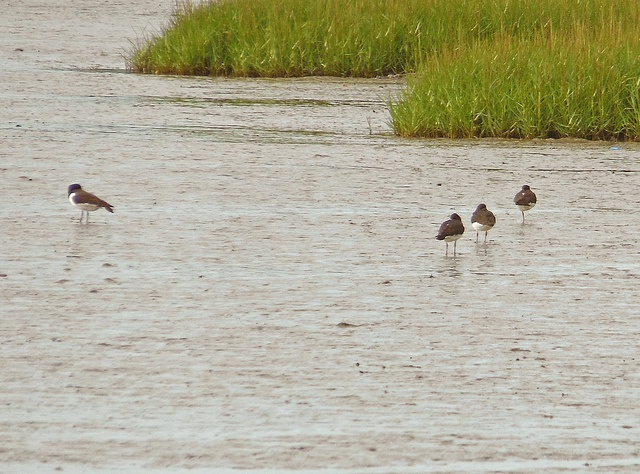Describe the objects in this image and their specific colors. I can see bird in darkgray, gray, and maroon tones, bird in darkgray, black, gray, and maroon tones, bird in darkgray, maroon, and gray tones, and bird in darkgray, gray, brown, and lightgray tones in this image. 